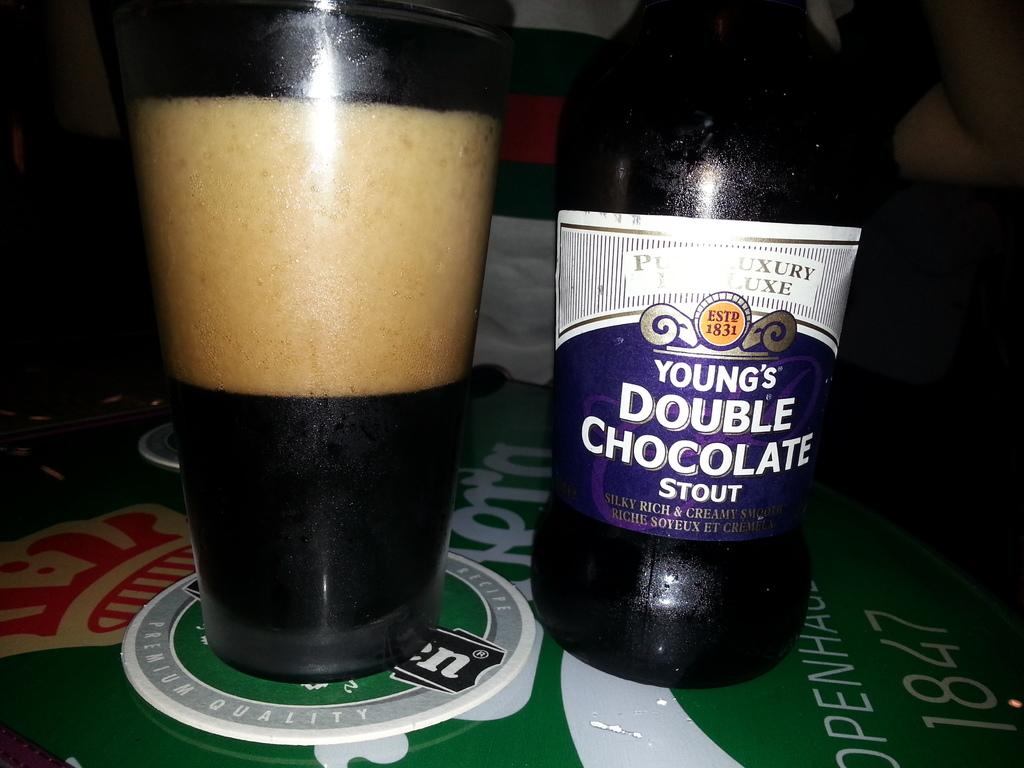Is this a stout?
Provide a short and direct response. Yes. 